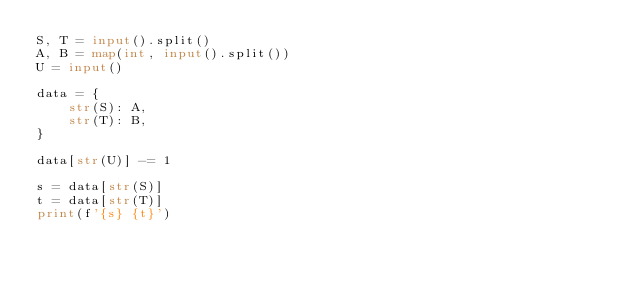<code> <loc_0><loc_0><loc_500><loc_500><_Python_>S, T = input().split()
A, B = map(int, input().split())
U = input()

data = {
    str(S): A,
    str(T): B,
}

data[str(U)] -= 1

s = data[str(S)]
t = data[str(T)]
print(f'{s} {t}')</code> 